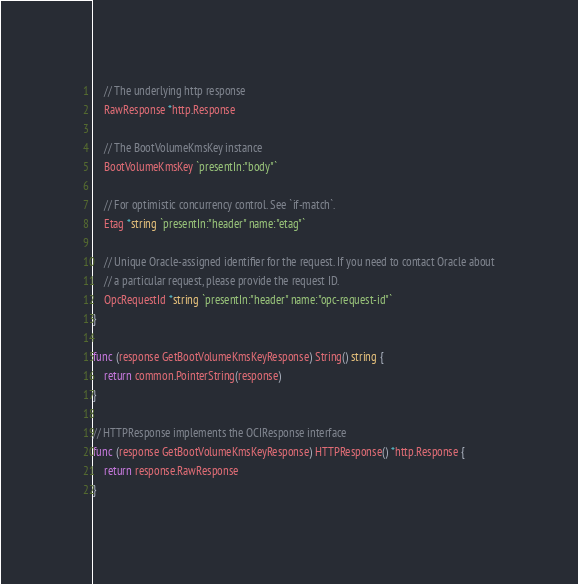Convert code to text. <code><loc_0><loc_0><loc_500><loc_500><_Go_>
	// The underlying http response
	RawResponse *http.Response

	// The BootVolumeKmsKey instance
	BootVolumeKmsKey `presentIn:"body"`

	// For optimistic concurrency control. See `if-match`.
	Etag *string `presentIn:"header" name:"etag"`

	// Unique Oracle-assigned identifier for the request. If you need to contact Oracle about
	// a particular request, please provide the request ID.
	OpcRequestId *string `presentIn:"header" name:"opc-request-id"`
}

func (response GetBootVolumeKmsKeyResponse) String() string {
	return common.PointerString(response)
}

// HTTPResponse implements the OCIResponse interface
func (response GetBootVolumeKmsKeyResponse) HTTPResponse() *http.Response {
	return response.RawResponse
}
</code> 